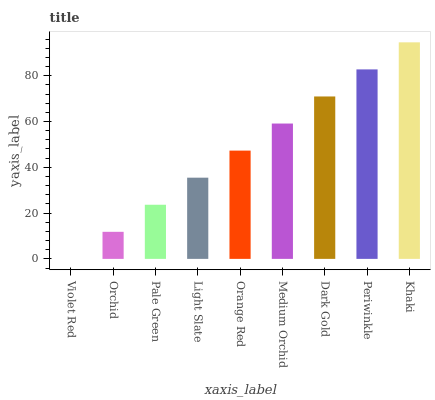Is Violet Red the minimum?
Answer yes or no. Yes. Is Khaki the maximum?
Answer yes or no. Yes. Is Orchid the minimum?
Answer yes or no. No. Is Orchid the maximum?
Answer yes or no. No. Is Orchid greater than Violet Red?
Answer yes or no. Yes. Is Violet Red less than Orchid?
Answer yes or no. Yes. Is Violet Red greater than Orchid?
Answer yes or no. No. Is Orchid less than Violet Red?
Answer yes or no. No. Is Orange Red the high median?
Answer yes or no. Yes. Is Orange Red the low median?
Answer yes or no. Yes. Is Dark Gold the high median?
Answer yes or no. No. Is Orchid the low median?
Answer yes or no. No. 